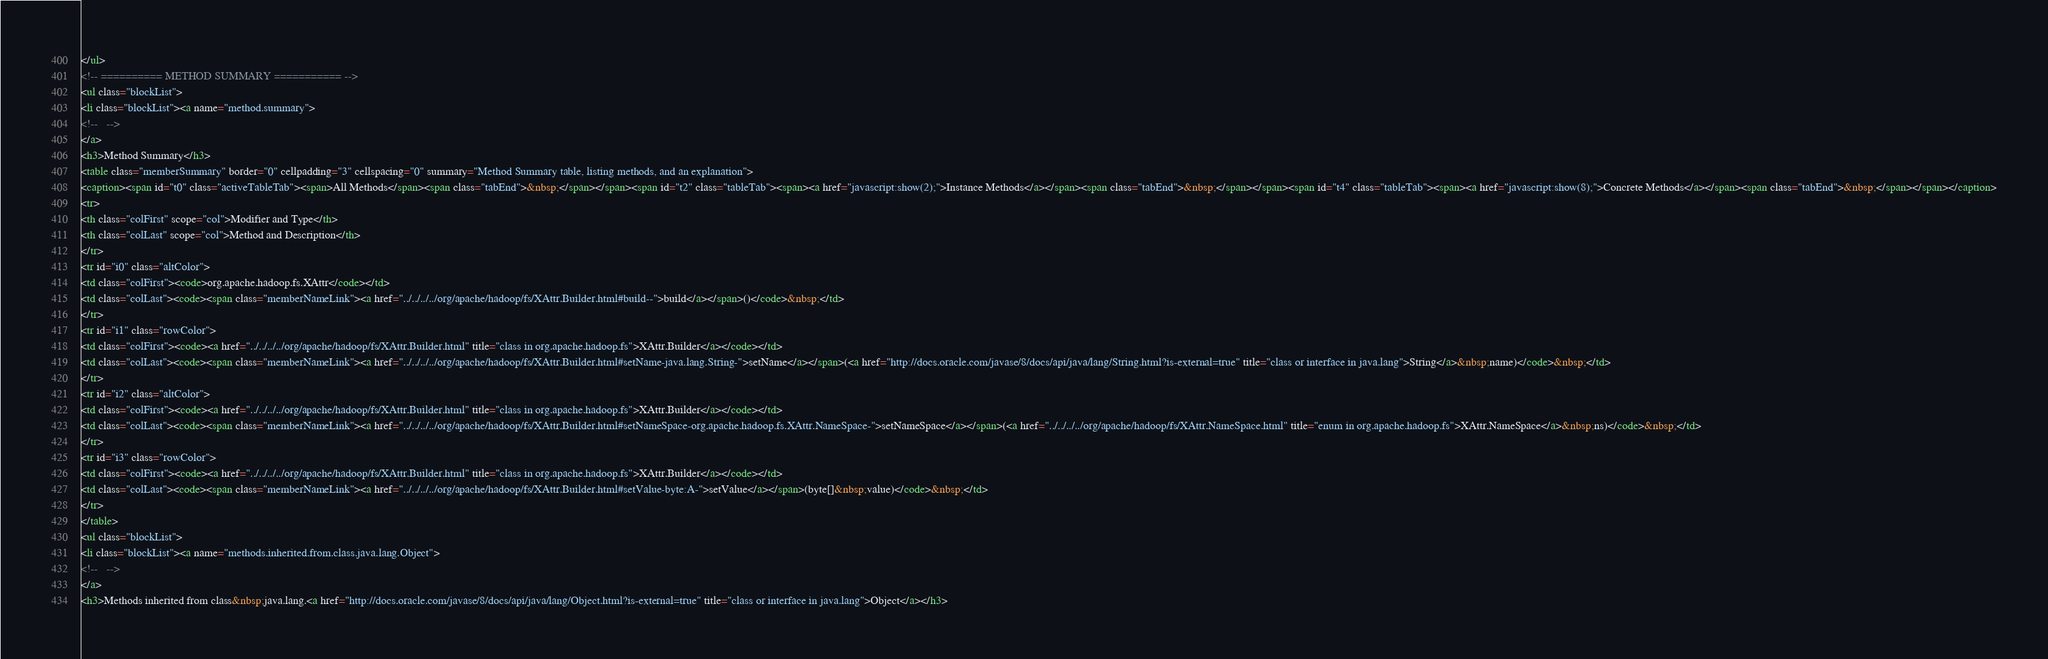<code> <loc_0><loc_0><loc_500><loc_500><_HTML_></ul>
<!-- ========== METHOD SUMMARY =========== -->
<ul class="blockList">
<li class="blockList"><a name="method.summary">
<!--   -->
</a>
<h3>Method Summary</h3>
<table class="memberSummary" border="0" cellpadding="3" cellspacing="0" summary="Method Summary table, listing methods, and an explanation">
<caption><span id="t0" class="activeTableTab"><span>All Methods</span><span class="tabEnd">&nbsp;</span></span><span id="t2" class="tableTab"><span><a href="javascript:show(2);">Instance Methods</a></span><span class="tabEnd">&nbsp;</span></span><span id="t4" class="tableTab"><span><a href="javascript:show(8);">Concrete Methods</a></span><span class="tabEnd">&nbsp;</span></span></caption>
<tr>
<th class="colFirst" scope="col">Modifier and Type</th>
<th class="colLast" scope="col">Method and Description</th>
</tr>
<tr id="i0" class="altColor">
<td class="colFirst"><code>org.apache.hadoop.fs.XAttr</code></td>
<td class="colLast"><code><span class="memberNameLink"><a href="../../../../org/apache/hadoop/fs/XAttr.Builder.html#build--">build</a></span>()</code>&nbsp;</td>
</tr>
<tr id="i1" class="rowColor">
<td class="colFirst"><code><a href="../../../../org/apache/hadoop/fs/XAttr.Builder.html" title="class in org.apache.hadoop.fs">XAttr.Builder</a></code></td>
<td class="colLast"><code><span class="memberNameLink"><a href="../../../../org/apache/hadoop/fs/XAttr.Builder.html#setName-java.lang.String-">setName</a></span>(<a href="http://docs.oracle.com/javase/8/docs/api/java/lang/String.html?is-external=true" title="class or interface in java.lang">String</a>&nbsp;name)</code>&nbsp;</td>
</tr>
<tr id="i2" class="altColor">
<td class="colFirst"><code><a href="../../../../org/apache/hadoop/fs/XAttr.Builder.html" title="class in org.apache.hadoop.fs">XAttr.Builder</a></code></td>
<td class="colLast"><code><span class="memberNameLink"><a href="../../../../org/apache/hadoop/fs/XAttr.Builder.html#setNameSpace-org.apache.hadoop.fs.XAttr.NameSpace-">setNameSpace</a></span>(<a href="../../../../org/apache/hadoop/fs/XAttr.NameSpace.html" title="enum in org.apache.hadoop.fs">XAttr.NameSpace</a>&nbsp;ns)</code>&nbsp;</td>
</tr>
<tr id="i3" class="rowColor">
<td class="colFirst"><code><a href="../../../../org/apache/hadoop/fs/XAttr.Builder.html" title="class in org.apache.hadoop.fs">XAttr.Builder</a></code></td>
<td class="colLast"><code><span class="memberNameLink"><a href="../../../../org/apache/hadoop/fs/XAttr.Builder.html#setValue-byte:A-">setValue</a></span>(byte[]&nbsp;value)</code>&nbsp;</td>
</tr>
</table>
<ul class="blockList">
<li class="blockList"><a name="methods.inherited.from.class.java.lang.Object">
<!--   -->
</a>
<h3>Methods inherited from class&nbsp;java.lang.<a href="http://docs.oracle.com/javase/8/docs/api/java/lang/Object.html?is-external=true" title="class or interface in java.lang">Object</a></h3></code> 